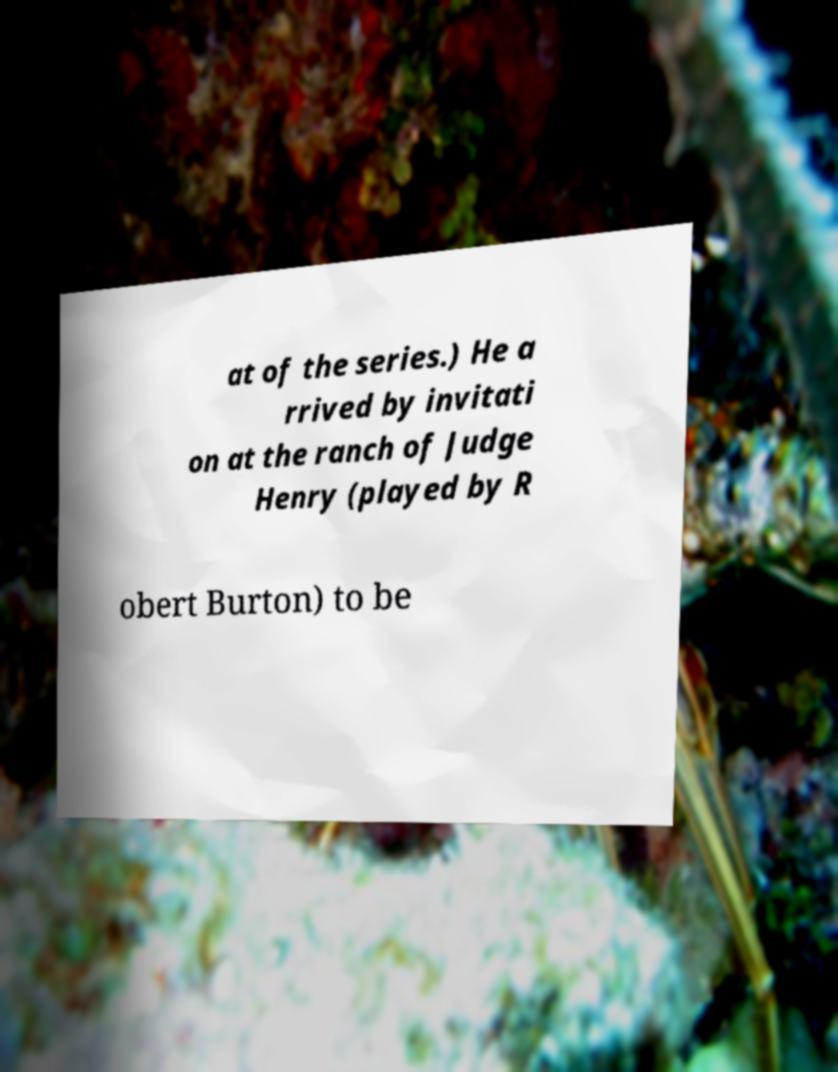For documentation purposes, I need the text within this image transcribed. Could you provide that? at of the series.) He a rrived by invitati on at the ranch of Judge Henry (played by R obert Burton) to be 